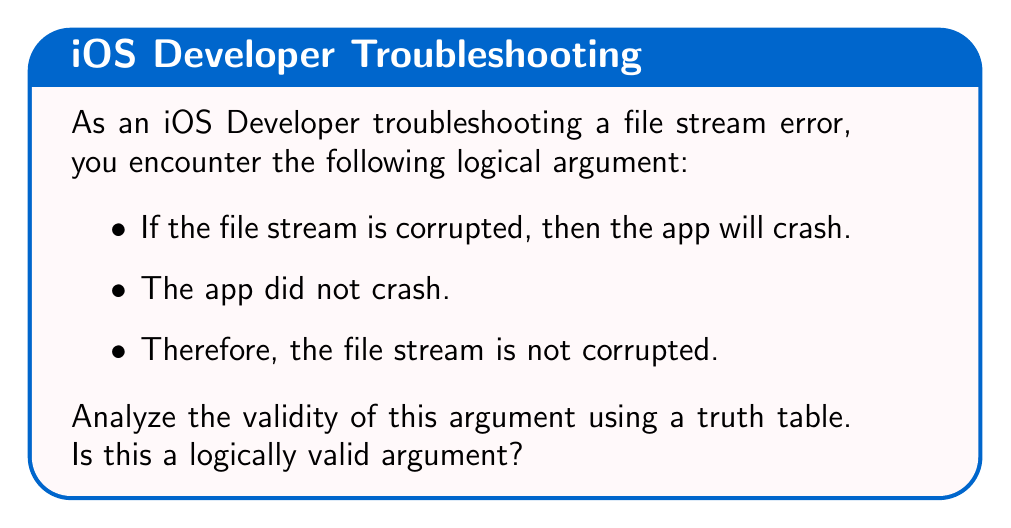Teach me how to tackle this problem. Let's analyze this argument step by step using a truth table:

1. Define our propositions:
   p: The file stream is corrupted
   q: The app will crash

2. The logical structure of the argument is:
   Premise 1: p → q (If p, then q)
   Premise 2: ¬q (not q)
   Conclusion: ¬p (not p)

3. Construct the truth table:

   $$
   \begin{array}{|c|c|c|c|c|c|}
   \hline
   p & q & p \rightarrow q & \neg q & \neg p & (p \rightarrow q) \land \neg q \rightarrow \neg p \\
   \hline
   T & T & T & F & F & T \\
   T & F & F & T & F & T \\
   F & T & T & F & T & T \\
   F & F & T & T & T & T \\
   \hline
   \end{array}
   $$

4. Analyze the truth table:
   - The argument is valid if and only if the final column is always true.
   - We see that the final column is indeed always true.

5. Interpretation:
   This argument form is known as "Modus Tollens" (denying the consequent). It is a valid logical argument form.

However, it's important to note that while the argument is logically valid, it may not always lead to a true conclusion in real-world scenarios. There could be other reasons why the app didn't crash, even if the file stream is corrupted.
Answer: Valid argument 